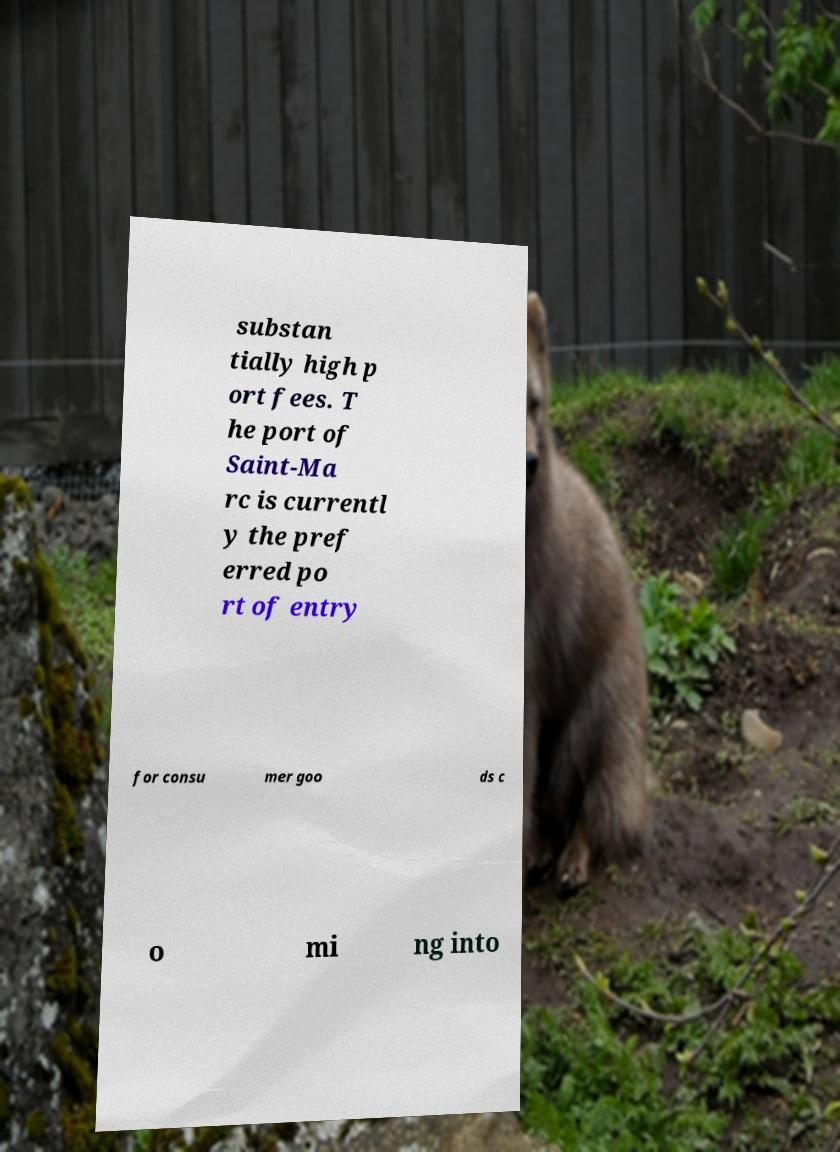There's text embedded in this image that I need extracted. Can you transcribe it verbatim? substan tially high p ort fees. T he port of Saint-Ma rc is currentl y the pref erred po rt of entry for consu mer goo ds c o mi ng into 